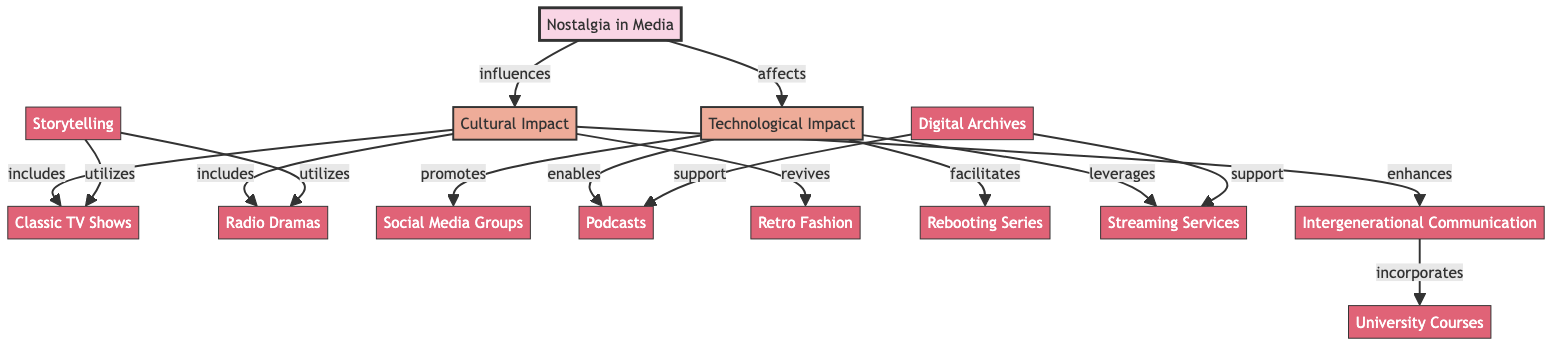What is the main subject of the diagram? The diagram focuses on "Nostalgia in Media," represented as the root node. It links cultural and technological impacts to various media forms.
Answer: Nostalgia in Media How many nodes are present in the diagram? By counting the individual entities listed, there are 13 nodes.
Answer: 13 Which node is connected to "Cultural Impact"? The nodes "Classic TV Shows," "Radio Dramas," "Retro Fashion," and "Intergenerational Communication" are directly connected to "Cultural Impact."
Answer: Classic TV Shows, Radio Dramas, Retro Fashion, Intergenerational Communication What type of connections does "Technological Impact" have? "Technological Impact" connects to "Social Media Groups," "Podcasts," "Rebooting Series," and "Streaming Services" through different types of influence such as promotes and enables.
Answer: promotes, enables, facilitates, leverages How does "Nostalgia in Media" affect the technological impact? The relationship is defined as "affects," indicating that nostalgia shapes the way technology influences media platforms and interactions.
Answer: affects Which node incorporates "University Courses"? "Intergenerational Communication" is the node that incorporates or includes "University Courses," showing its relevance in academic settings.
Answer: Intergenerational Communication What is supported by "Digital Archives"? "Podcasts" and "Streaming Services" are both supported by "Digital Archives," emphasizing their reliance on historical content.
Answer: Podcasts, Streaming Services Which nodes utilize storytelling? The nodes "Classic TV Shows" and "Radio Dramas" utilize storytelling, indicating their reliance on narrative techniques.
Answer: Classic TV Shows, Radio Dramas Why is "Retro Fashion" connected to "Cultural Impact"? "Retro Fashion" is described as being revived within the context of "Cultural Impact," suggesting nostalgia influences current fashion trends.
Answer: revives 